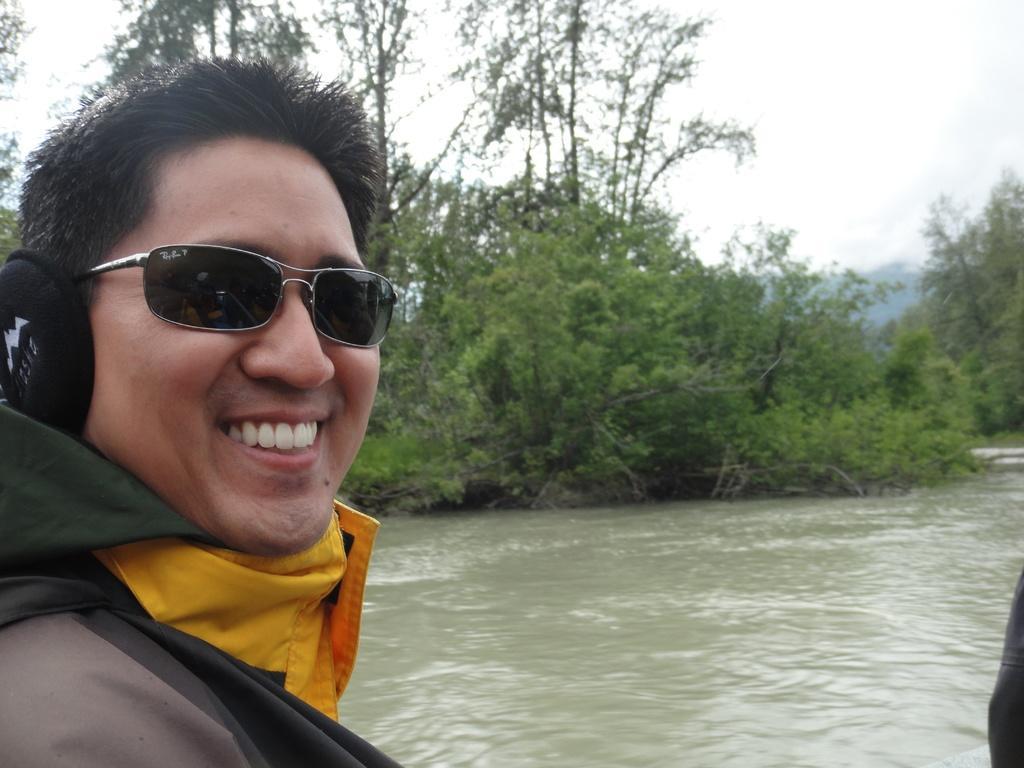Could you give a brief overview of what you see in this image? In this image I can see the person to the side of water. The person is wearing yellow, black and grey color dress and also the goggles. In the back I can see many trees and the white sky. 